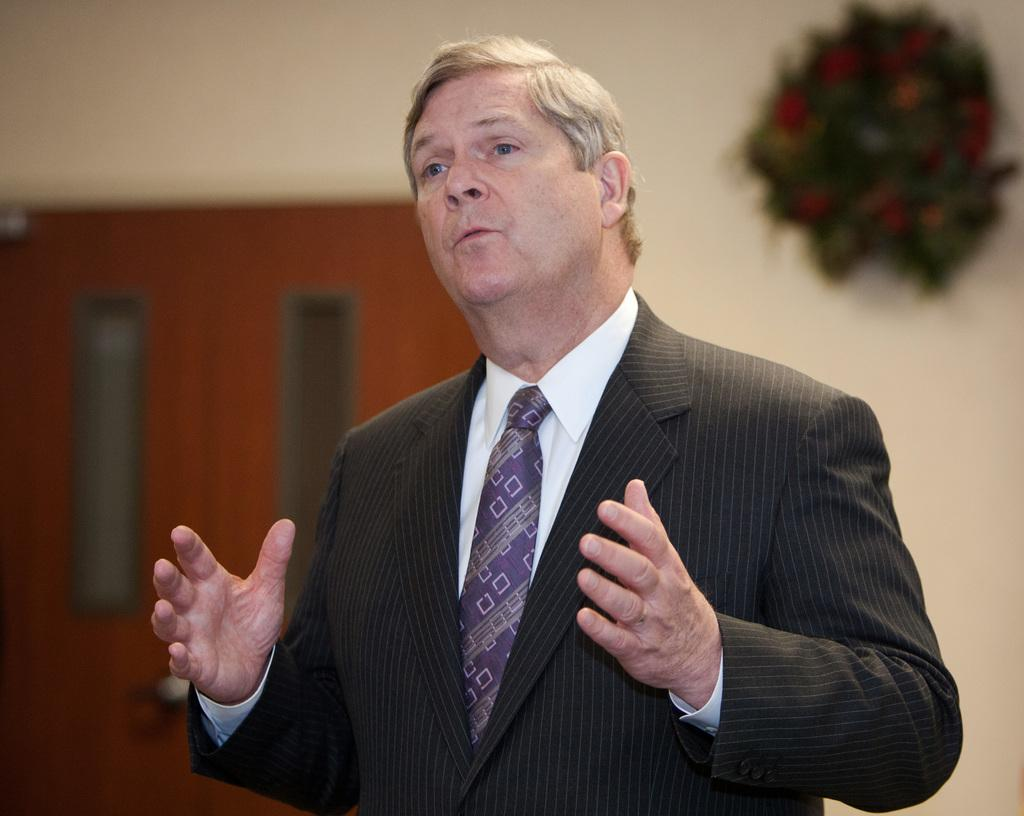What is the person in the image wearing? The person in the image is wearing a black color jacket. What can be seen in the background of the image? There is a wall in the background of the image. What is hanging on the wall in the image? There is a flower bookey on the wall. Where is the door located in the image? The door is on the left side of the image. What type of crayon is the person using to draw on the wall in the image? There is no crayon or drawing activity present in the image. 